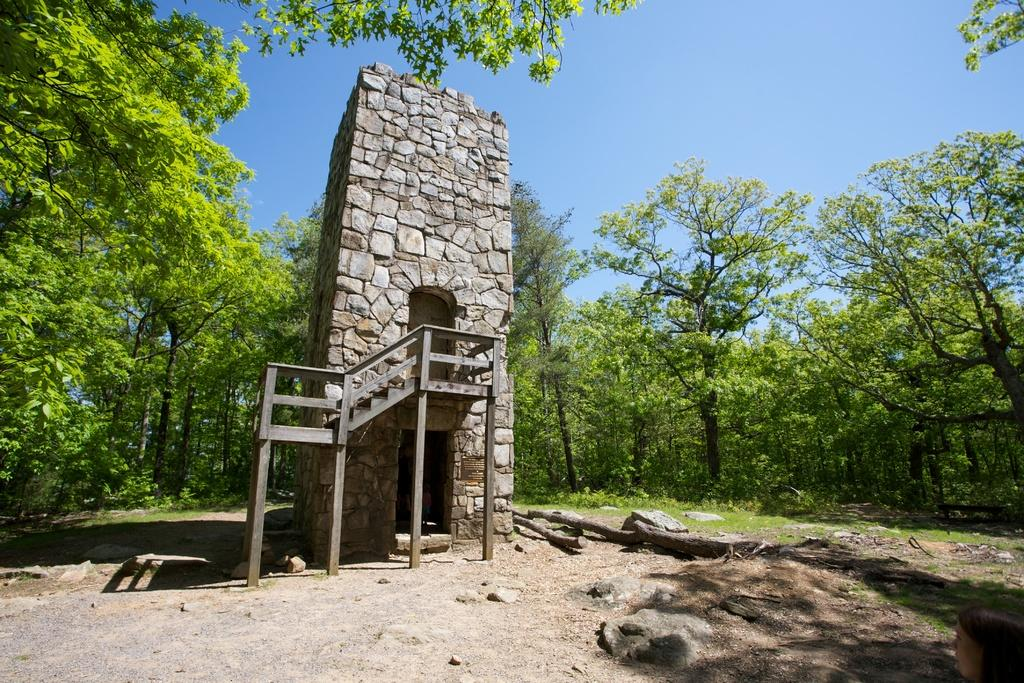What type of house is in the center of the image? There is a stone house with a staircase in the center of the image. What can be seen in the background of the image? There are trees and the sky visible in the background of the image. What is at the bottom of the image? There is ground at the bottom of the image. What type of advertisement can be seen on the side of the stone house? There is no advertisement present on the side of the stone house in the image. What does the mother do in the image? There is no mother present in the image. 